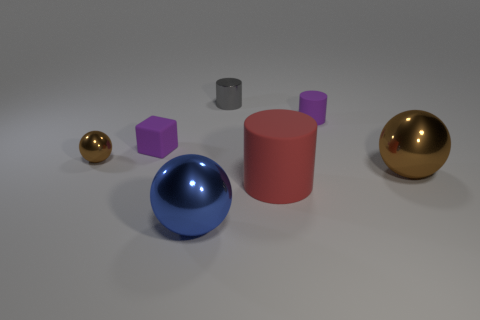Subtract all matte cylinders. How many cylinders are left? 1 Subtract all blue spheres. How many spheres are left? 2 Subtract 1 balls. How many balls are left? 2 Add 2 tiny gray metal objects. How many objects exist? 9 Subtract 0 blue blocks. How many objects are left? 7 Subtract all cylinders. How many objects are left? 4 Subtract all brown cylinders. Subtract all red spheres. How many cylinders are left? 3 Subtract all brown cylinders. How many yellow blocks are left? 0 Subtract all large things. Subtract all tiny matte cylinders. How many objects are left? 3 Add 1 big brown shiny things. How many big brown shiny things are left? 2 